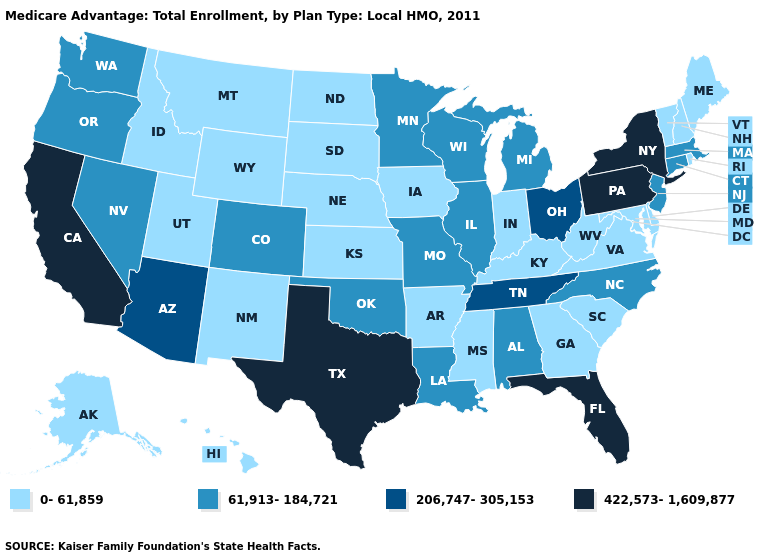Does Wyoming have the same value as Pennsylvania?
Be succinct. No. Which states have the lowest value in the Northeast?
Keep it brief. Maine, New Hampshire, Rhode Island, Vermont. What is the value of Mississippi?
Be succinct. 0-61,859. Does New York have the highest value in the Northeast?
Short answer required. Yes. What is the highest value in the USA?
Quick response, please. 422,573-1,609,877. What is the value of Nebraska?
Concise answer only. 0-61,859. Among the states that border Arkansas , does Oklahoma have the lowest value?
Short answer required. No. Name the states that have a value in the range 0-61,859?
Short answer required. Alaska, Arkansas, Delaware, Georgia, Hawaii, Iowa, Idaho, Indiana, Kansas, Kentucky, Maryland, Maine, Mississippi, Montana, North Dakota, Nebraska, New Hampshire, New Mexico, Rhode Island, South Carolina, South Dakota, Utah, Virginia, Vermont, West Virginia, Wyoming. Which states hav the highest value in the Northeast?
Give a very brief answer. New York, Pennsylvania. Does the map have missing data?
Keep it brief. No. Does Maine have a higher value than West Virginia?
Quick response, please. No. What is the value of Connecticut?
Give a very brief answer. 61,913-184,721. What is the value of Minnesota?
Answer briefly. 61,913-184,721. What is the highest value in the West ?
Give a very brief answer. 422,573-1,609,877. 